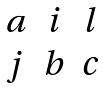<formula> <loc_0><loc_0><loc_500><loc_500>\begin{matrix} a & i & l \\ j & b & c \end{matrix}</formula> 